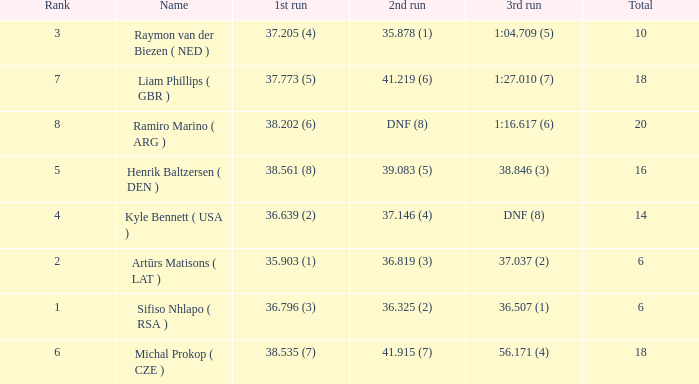Which 3rd run has rank of 1? 36.507 (1). 